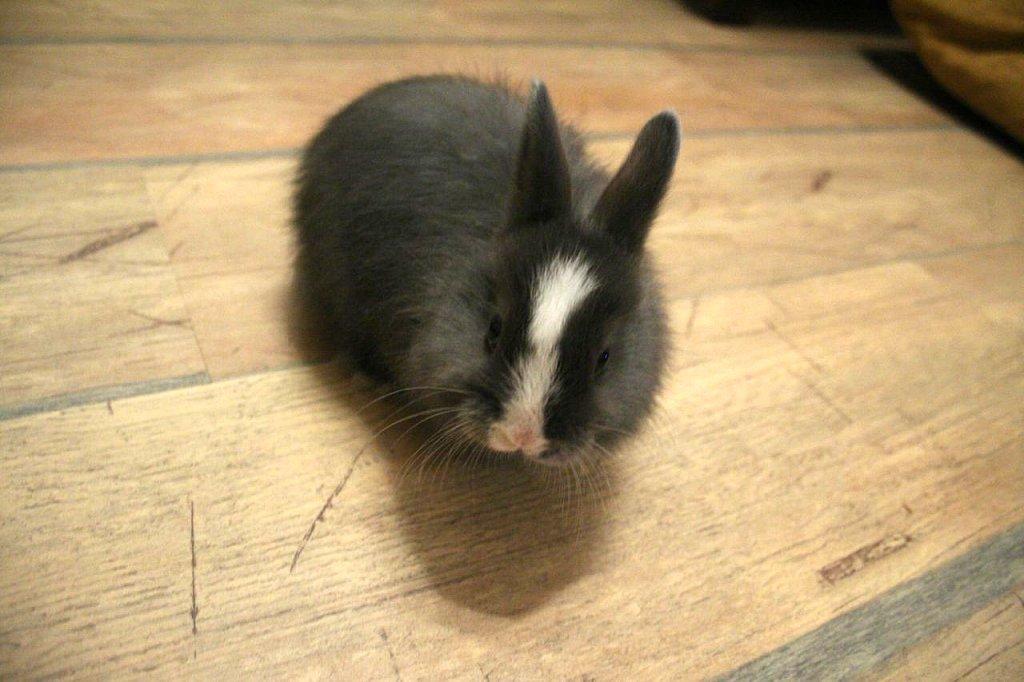Could you give a brief overview of what you see in this image? In the middle of this image, there is an animal in the black and white color combination on a wooden surface. In the background, there is an object. 